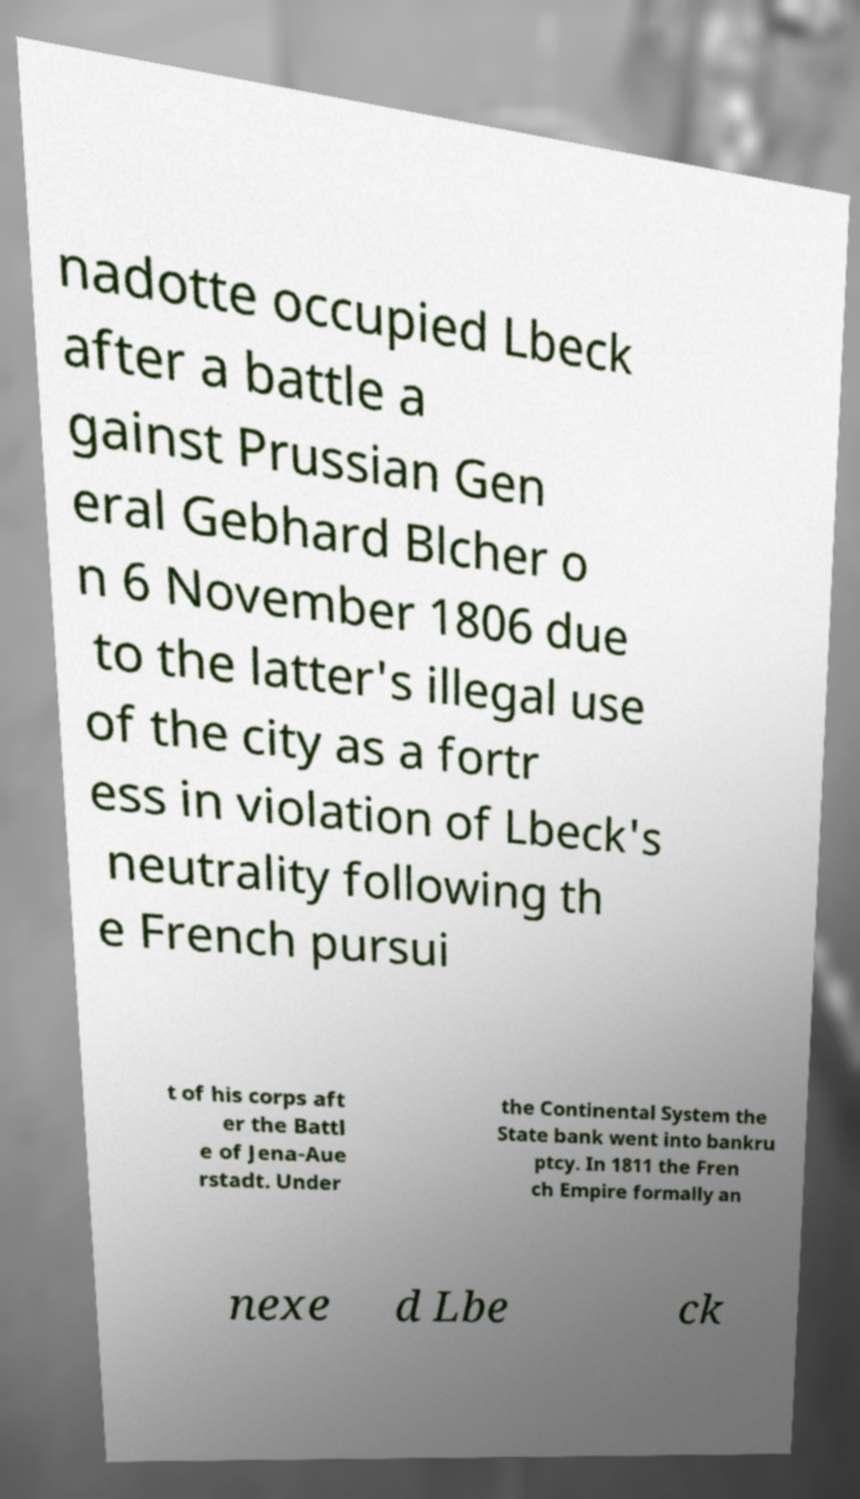There's text embedded in this image that I need extracted. Can you transcribe it verbatim? nadotte occupied Lbeck after a battle a gainst Prussian Gen eral Gebhard Blcher o n 6 November 1806 due to the latter's illegal use of the city as a fortr ess in violation of Lbeck's neutrality following th e French pursui t of his corps aft er the Battl e of Jena-Aue rstadt. Under the Continental System the State bank went into bankru ptcy. In 1811 the Fren ch Empire formally an nexe d Lbe ck 